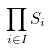Convert formula to latex. <formula><loc_0><loc_0><loc_500><loc_500>\prod _ { i \in I } S _ { i }</formula> 